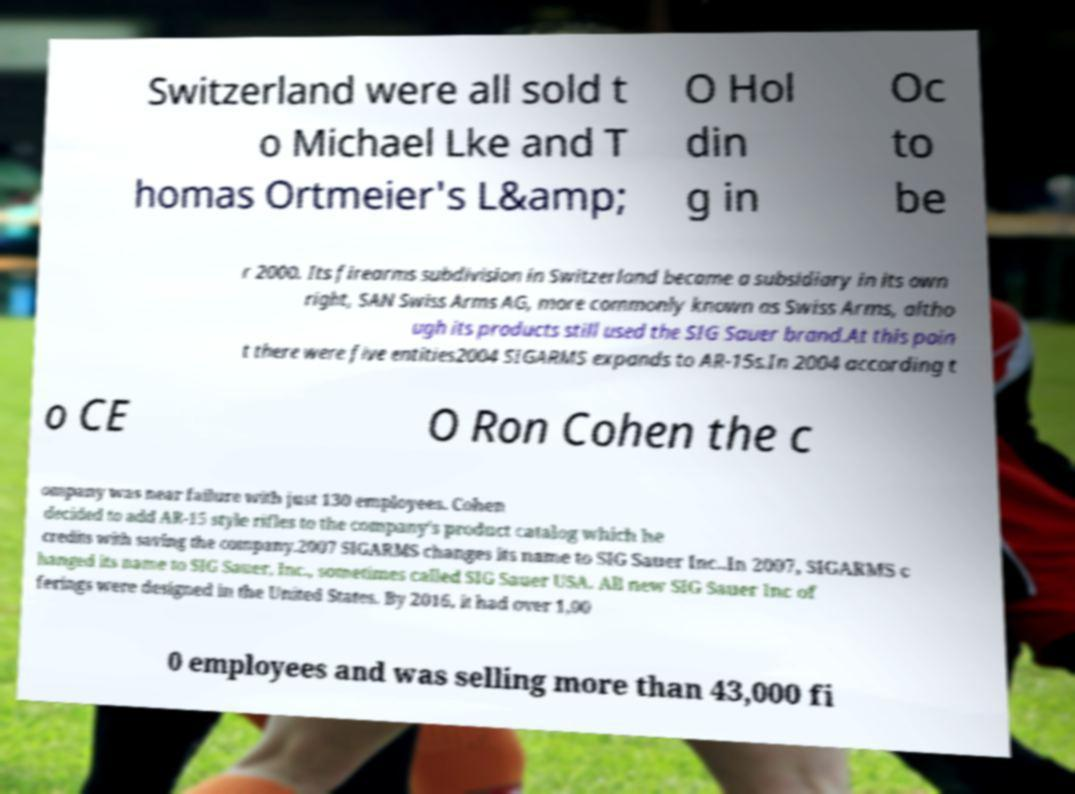Please read and relay the text visible in this image. What does it say? Switzerland were all sold t o Michael Lke and T homas Ortmeier's L&amp; O Hol din g in Oc to be r 2000. Its firearms subdivision in Switzerland became a subsidiary in its own right, SAN Swiss Arms AG, more commonly known as Swiss Arms, altho ugh its products still used the SIG Sauer brand.At this poin t there were five entities2004 SIGARMS expands to AR-15s.In 2004 according t o CE O Ron Cohen the c ompany was near failure with just 130 employees. Cohen decided to add AR-15 style rifles to the company's product catalog which he credits with saving the company.2007 SIGARMS changes its name to SIG Sauer Inc..In 2007, SIGARMS c hanged its name to SIG Sauer, Inc., sometimes called SIG Sauer USA. All new SIG Sauer Inc of ferings were designed in the United States. By 2016, it had over 1,00 0 employees and was selling more than 43,000 fi 